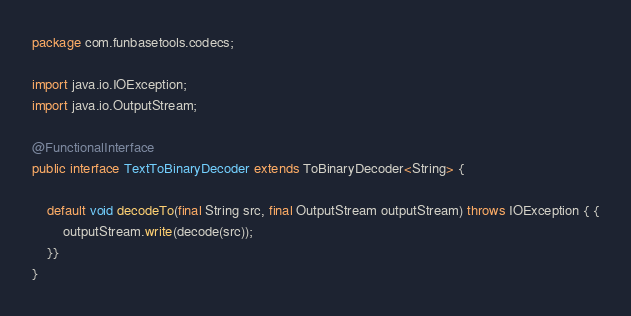<code> <loc_0><loc_0><loc_500><loc_500><_Java_>package com.funbasetools.codecs;

import java.io.IOException;
import java.io.OutputStream;

@FunctionalInterface
public interface TextToBinaryDecoder extends ToBinaryDecoder<String> {

    default void decodeTo(final String src, final OutputStream outputStream) throws IOException { {
        outputStream.write(decode(src));
    }}
}
</code> 